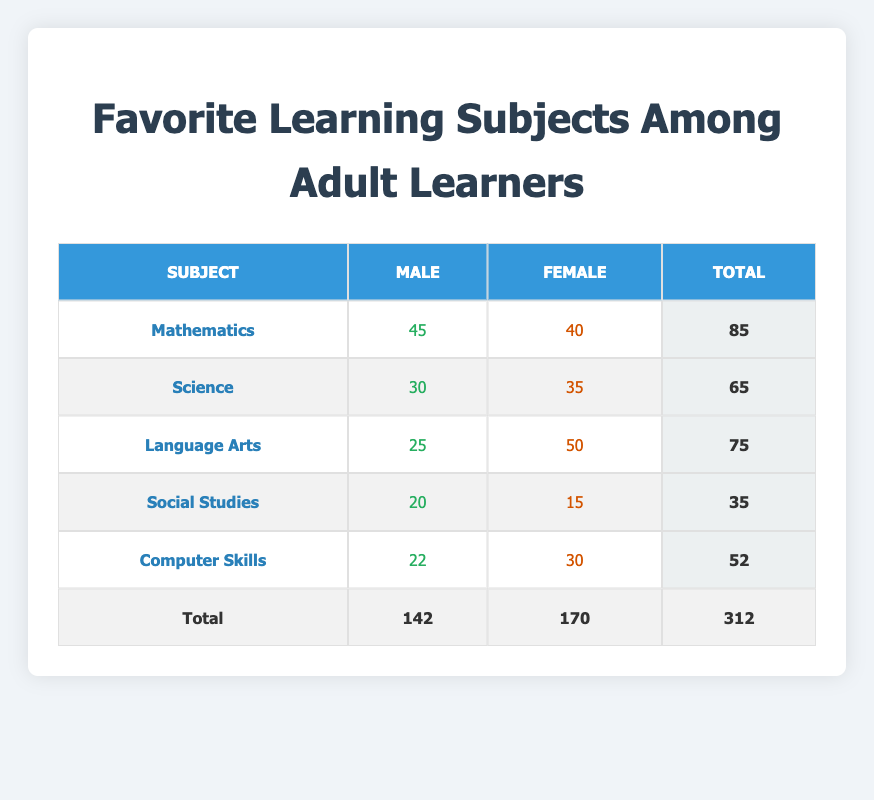What is the total number of male learners who prefer Mathematics? Referring to the table, the count of male learners who chose Mathematics is explicitly listed as 45.
Answer: 45 What is the total number of female learners who prefer Science? According to the table, the count of female learners who preferred Science is 35.
Answer: 35 Which subject has the highest number of female learners? By comparing the counts in the female column, Language Arts has the highest count at 50, making it the favorite subject among female learners.
Answer: Language Arts What is the difference in the number of male and female learners who prefer Computer Skills? The count of male learners who prefer Computer Skills is 22, and for female learners, it is 30. Calculating the difference: 30 - 22 = 8.
Answer: 8 Is it true that more female learners prefer Mathematics than male learners? The table shows that female learners have a count of 40 for Mathematics, while male learners have 45. Since 40 is less than 45, the statement is false.
Answer: No Which subject has the lowest total count among all learners? Adding the totals for each subject: Mathematics (85), Science (65), Language Arts (75), Social Studies (35), and Computer Skills (52). The lowest total is for Social Studies, which has 35.
Answer: Social Studies What is the combined total of all learners who prefer Language Arts and Science? The counts for Language Arts is 75, and Science is 65. Summing these gives: 75 + 65 = 140.
Answer: 140 What percentage of the total learners are male? The total count of male learners is 142, and the overall count of learners is 312. To calculate the percentage: (142/312) * 100 ≈ 45.45%.
Answer: 45.45% What is the average number of learners for each subject? The total counts are Mathematics (85), Science (65), Language Arts (75), Social Studies (35), and Computer Skills (52). The total number of learners is 312. To find the average: (85 + 65 + 75 + 35 + 52) / 5 = 62.
Answer: 62 